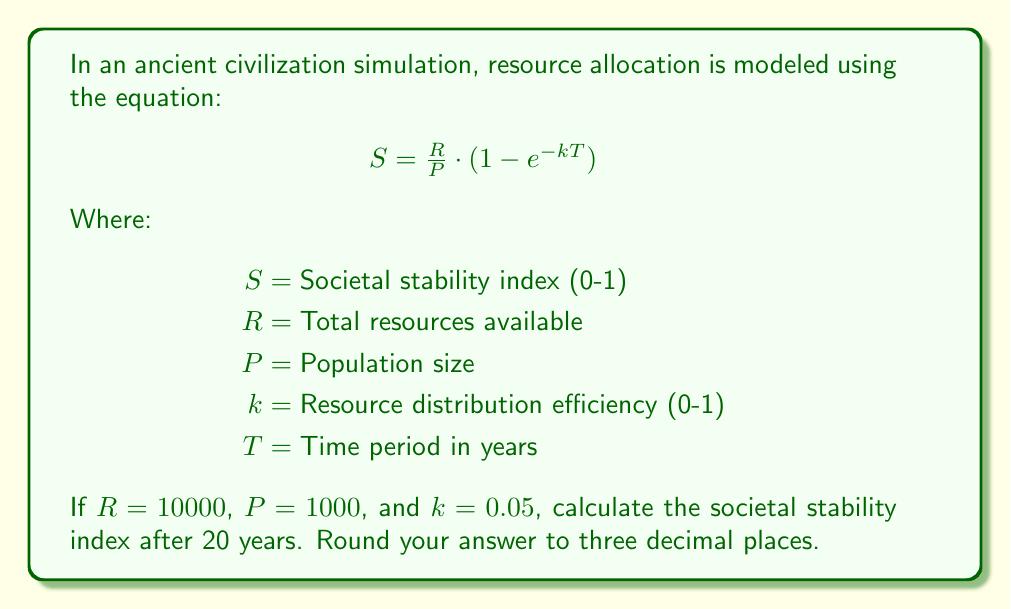Show me your answer to this math problem. To solve this problem, we'll follow these steps:

1) We have the equation:
   $$S = \frac{R}{P} \cdot (1 - e^{-kT})$$

2) We're given the following values:
   $R = 10000$
   $P = 1000$
   $k = 0.05$
   $T = 20$

3) Let's start by calculating $\frac{R}{P}$:
   $$\frac{R}{P} = \frac{10000}{1000} = 10$$

4) Now, let's calculate the exponential term $e^{-kT}$:
   $$e^{-kT} = e^{-0.05 \cdot 20} = e^{-1} \approx 0.3679$$

5) Now we can subtract this from 1:
   $$1 - e^{-kT} \approx 1 - 0.3679 = 0.6321$$

6) Finally, we multiply this by $\frac{R}{P}$:
   $$S = 10 \cdot 0.6321 = 6.321$$

7) Rounding to three decimal places:
   $$S \approx 6.321$$
Answer: 6.321 